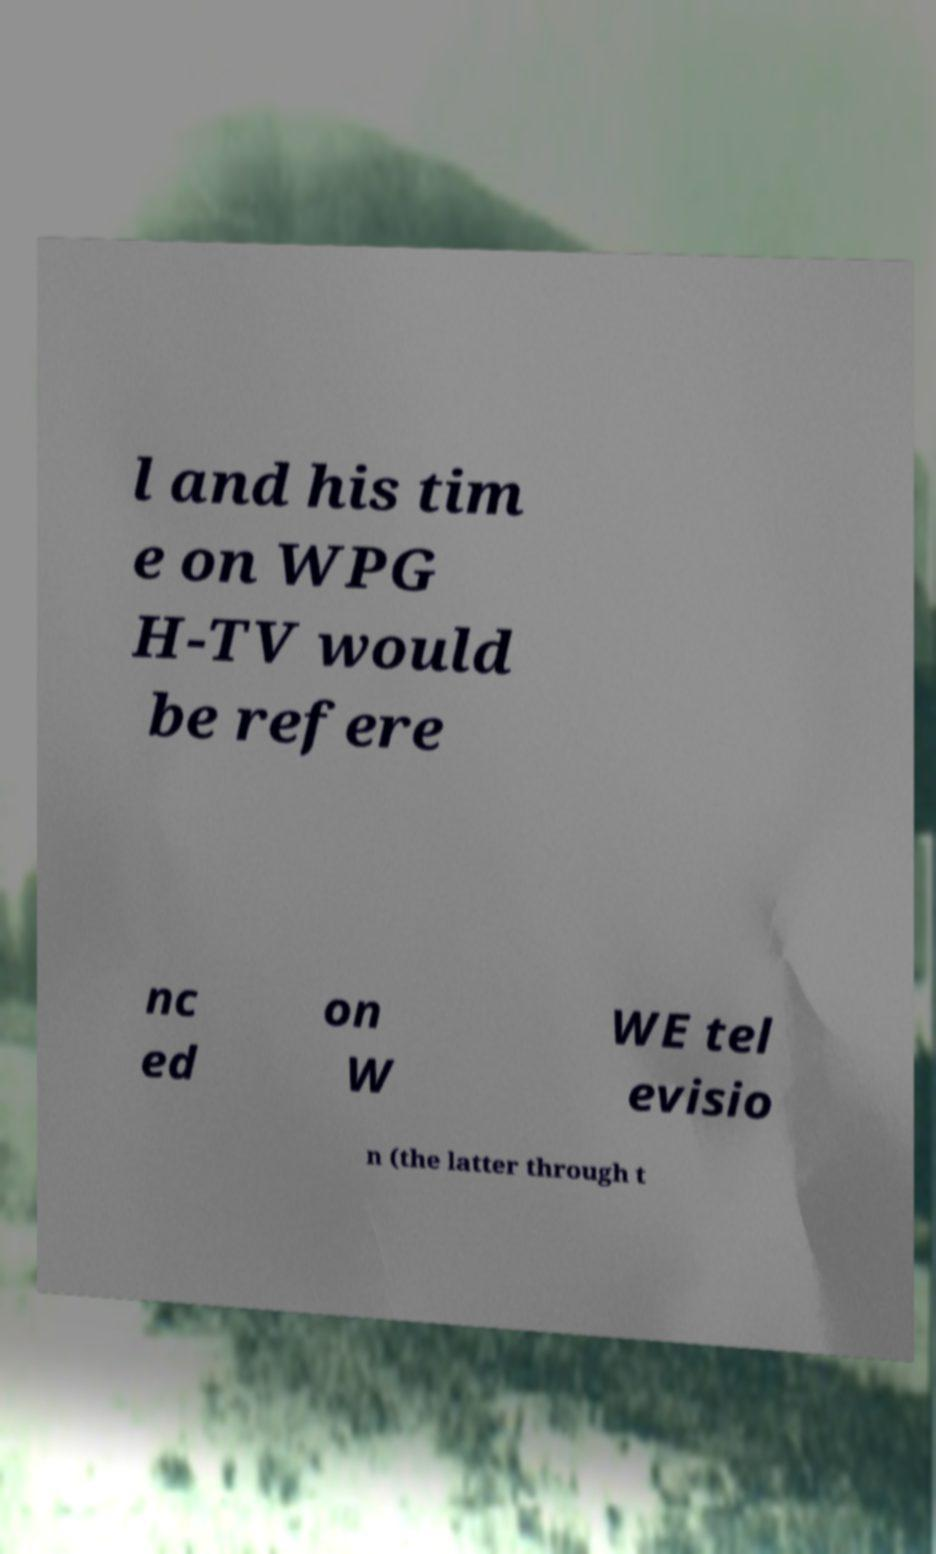What messages or text are displayed in this image? I need them in a readable, typed format. l and his tim e on WPG H-TV would be refere nc ed on W WE tel evisio n (the latter through t 